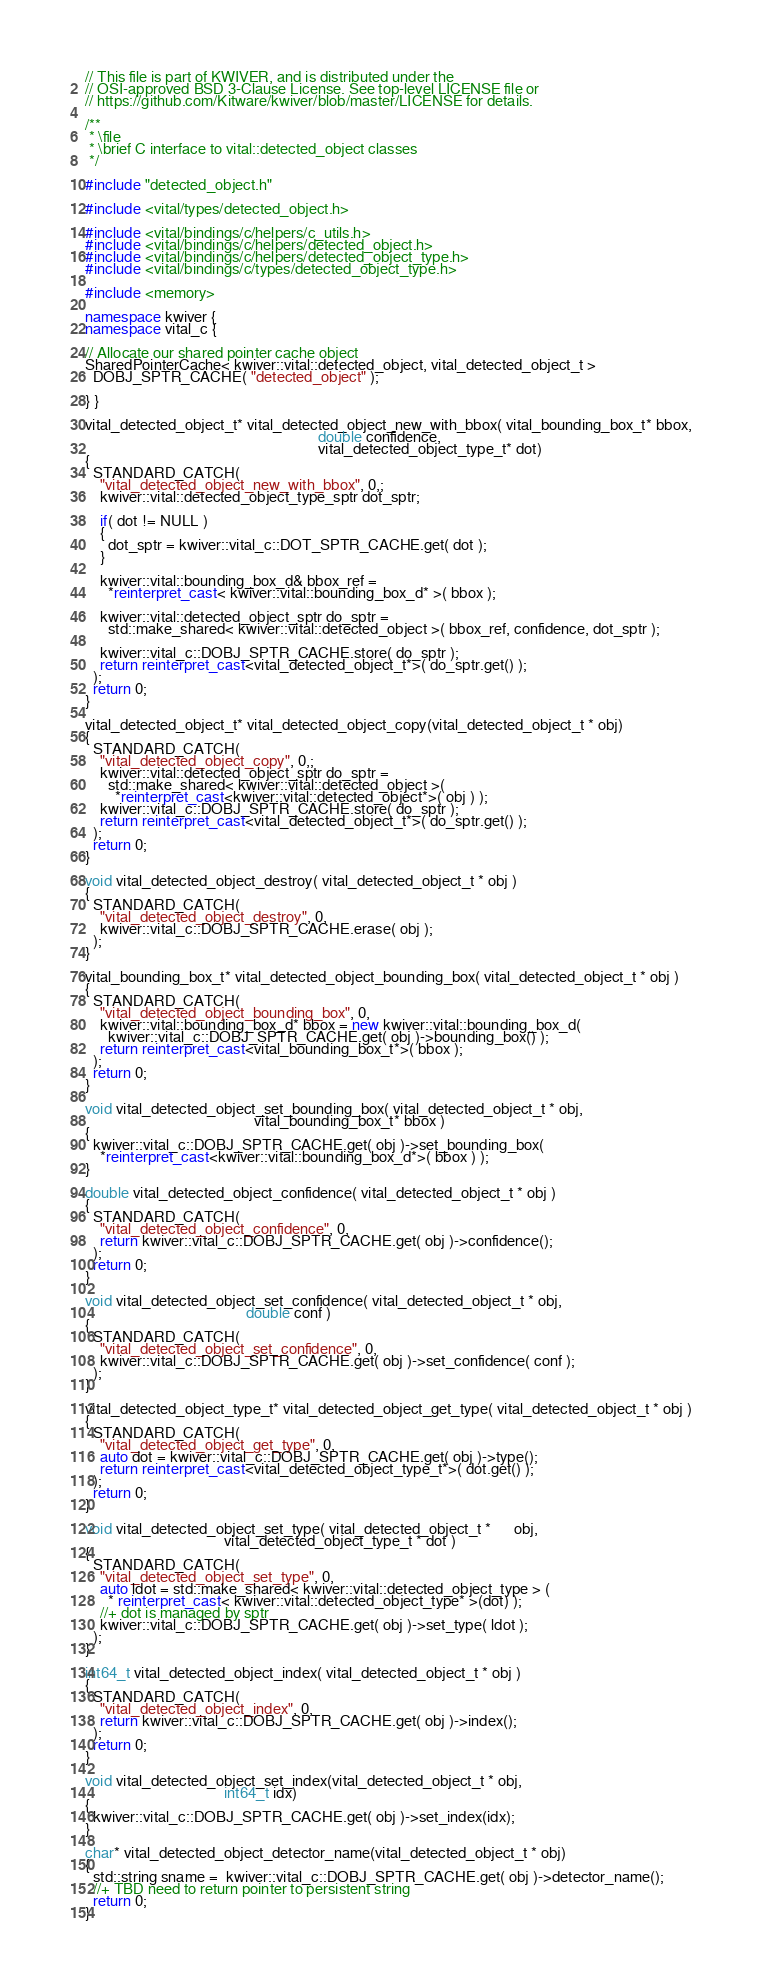Convert code to text. <code><loc_0><loc_0><loc_500><loc_500><_C++_>// This file is part of KWIVER, and is distributed under the
// OSI-approved BSD 3-Clause License. See top-level LICENSE file or
// https://github.com/Kitware/kwiver/blob/master/LICENSE for details.

/**
 * \file
 * \brief C interface to vital::detected_object classes
 */

#include "detected_object.h"

#include <vital/types/detected_object.h>

#include <vital/bindings/c/helpers/c_utils.h>
#include <vital/bindings/c/helpers/detected_object.h>
#include <vital/bindings/c/helpers/detected_object_type.h>
#include <vital/bindings/c/types/detected_object_type.h>

#include <memory>

namespace kwiver {
namespace vital_c {

// Allocate our shared pointer cache object
SharedPointerCache< kwiver::vital::detected_object, vital_detected_object_t >
  DOBJ_SPTR_CACHE( "detected_object" );

} }

vital_detected_object_t* vital_detected_object_new_with_bbox( vital_bounding_box_t* bbox,
                                                              double confidence,
                                                              vital_detected_object_type_t* dot)
{
  STANDARD_CATCH(
    "vital_detected_object_new_with_bbox", 0,;
    kwiver::vital::detected_object_type_sptr dot_sptr;

    if( dot != NULL )
    {
      dot_sptr = kwiver::vital_c::DOT_SPTR_CACHE.get( dot );
    }

    kwiver::vital::bounding_box_d& bbox_ref =
      *reinterpret_cast< kwiver::vital::bounding_box_d* >( bbox );

    kwiver::vital::detected_object_sptr do_sptr =
      std::make_shared< kwiver::vital::detected_object >( bbox_ref, confidence, dot_sptr );

    kwiver::vital_c::DOBJ_SPTR_CACHE.store( do_sptr );
    return reinterpret_cast<vital_detected_object_t*>( do_sptr.get() );
  );
  return 0;
}

vital_detected_object_t* vital_detected_object_copy(vital_detected_object_t * obj)
{
  STANDARD_CATCH(
    "vital_detected_object_copy", 0,;
    kwiver::vital::detected_object_sptr do_sptr =
      std::make_shared< kwiver::vital::detected_object >(
        *reinterpret_cast<kwiver::vital::detected_object*>( obj ) );
    kwiver::vital_c::DOBJ_SPTR_CACHE.store( do_sptr );
    return reinterpret_cast<vital_detected_object_t*>( do_sptr.get() );
  );
  return 0;
}

void vital_detected_object_destroy( vital_detected_object_t * obj )
{
  STANDARD_CATCH(
    "vital_detected_object_destroy", 0,
    kwiver::vital_c::DOBJ_SPTR_CACHE.erase( obj );
  );
}

vital_bounding_box_t* vital_detected_object_bounding_box( vital_detected_object_t * obj )
{
  STANDARD_CATCH(
    "vital_detected_object_bounding_box", 0,
    kwiver::vital::bounding_box_d* bbox = new kwiver::vital::bounding_box_d(
      kwiver::vital_c::DOBJ_SPTR_CACHE.get( obj )->bounding_box() );
    return reinterpret_cast<vital_bounding_box_t*>( bbox );
  );
  return 0;
}

void vital_detected_object_set_bounding_box( vital_detected_object_t * obj,
                                             vital_bounding_box_t* bbox )
{
  kwiver::vital_c::DOBJ_SPTR_CACHE.get( obj )->set_bounding_box(
    *reinterpret_cast<kwiver::vital::bounding_box_d*>( bbox ) );
}

double vital_detected_object_confidence( vital_detected_object_t * obj )
{
  STANDARD_CATCH(
    "vital_detected_object_confidence", 0,
    return kwiver::vital_c::DOBJ_SPTR_CACHE.get( obj )->confidence();
  );
  return 0;
}

void vital_detected_object_set_confidence( vital_detected_object_t * obj,
                                           double conf )
{
  STANDARD_CATCH(
    "vital_detected_object_set_confidence", 0,
    kwiver::vital_c::DOBJ_SPTR_CACHE.get( obj )->set_confidence( conf );
  );
}

vital_detected_object_type_t* vital_detected_object_get_type( vital_detected_object_t * obj )
{
  STANDARD_CATCH(
    "vital_detected_object_get_type", 0,
    auto dot = kwiver::vital_c::DOBJ_SPTR_CACHE.get( obj )->type();
    return reinterpret_cast<vital_detected_object_type_t*>( dot.get() );
  );
  return 0;
}

void vital_detected_object_set_type( vital_detected_object_t *      obj,
                                     vital_detected_object_type_t * dot )
{
  STANDARD_CATCH(
    "vital_detected_object_set_type", 0,
    auto ldot = std::make_shared< kwiver::vital::detected_object_type > (
      * reinterpret_cast< kwiver::vital::detected_object_type* >(dot) );
    //+ dot is managed by sptr
    kwiver::vital_c::DOBJ_SPTR_CACHE.get( obj )->set_type( ldot );
  );
}

int64_t vital_detected_object_index( vital_detected_object_t * obj )
{
  STANDARD_CATCH(
    "vital_detected_object_index", 0,
    return kwiver::vital_c::DOBJ_SPTR_CACHE.get( obj )->index();
  );
  return 0;
}

void vital_detected_object_set_index(vital_detected_object_t * obj,
                                     int64_t idx)
{
  kwiver::vital_c::DOBJ_SPTR_CACHE.get( obj )->set_index(idx);
}

char* vital_detected_object_detector_name(vital_detected_object_t * obj)
{
  std::string sname =  kwiver::vital_c::DOBJ_SPTR_CACHE.get( obj )->detector_name();
  //+ TBD need to return pointer to persistent string
  return 0;
}
</code> 